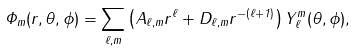<formula> <loc_0><loc_0><loc_500><loc_500>\Phi _ { m } ( r , \theta , \phi ) = \sum _ { \ell , m } \left ( A _ { \ell , m } r ^ { \ell } + D _ { \ell , m } r ^ { - ( \ell + 1 ) } \right ) Y _ { \ell } ^ { m } ( \theta , \phi ) ,</formula> 